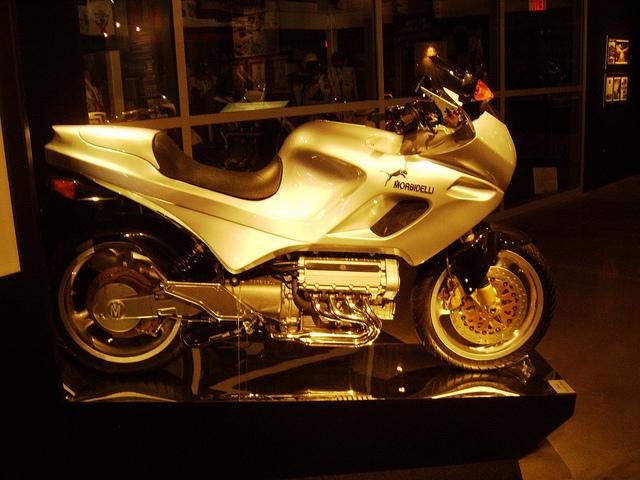What color is the bike?
Keep it brief. Gold. Is the bike real?
Short answer required. Yes. How many bikes are there?
Be succinct. 1. 